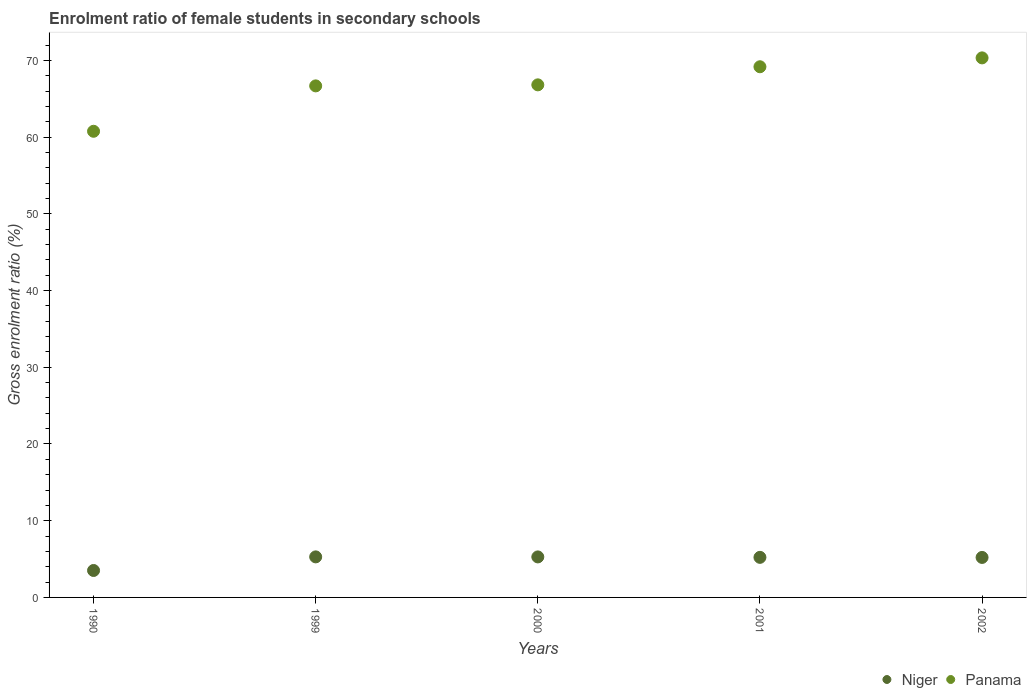How many different coloured dotlines are there?
Ensure brevity in your answer.  2. Is the number of dotlines equal to the number of legend labels?
Provide a succinct answer. Yes. What is the enrolment ratio of female students in secondary schools in Niger in 1999?
Keep it short and to the point. 5.28. Across all years, what is the maximum enrolment ratio of female students in secondary schools in Niger?
Offer a terse response. 5.28. Across all years, what is the minimum enrolment ratio of female students in secondary schools in Niger?
Your response must be concise. 3.51. In which year was the enrolment ratio of female students in secondary schools in Niger maximum?
Keep it short and to the point. 1999. In which year was the enrolment ratio of female students in secondary schools in Niger minimum?
Make the answer very short. 1990. What is the total enrolment ratio of female students in secondary schools in Panama in the graph?
Ensure brevity in your answer.  333.75. What is the difference between the enrolment ratio of female students in secondary schools in Niger in 1999 and that in 2002?
Your answer should be compact. 0.07. What is the difference between the enrolment ratio of female students in secondary schools in Niger in 2002 and the enrolment ratio of female students in secondary schools in Panama in 2000?
Provide a succinct answer. -61.6. What is the average enrolment ratio of female students in secondary schools in Niger per year?
Your answer should be compact. 4.9. In the year 2002, what is the difference between the enrolment ratio of female students in secondary schools in Panama and enrolment ratio of female students in secondary schools in Niger?
Give a very brief answer. 65.11. What is the ratio of the enrolment ratio of female students in secondary schools in Niger in 1990 to that in 1999?
Offer a terse response. 0.66. Is the difference between the enrolment ratio of female students in secondary schools in Panama in 1990 and 2000 greater than the difference between the enrolment ratio of female students in secondary schools in Niger in 1990 and 2000?
Offer a terse response. No. What is the difference between the highest and the second highest enrolment ratio of female students in secondary schools in Panama?
Keep it short and to the point. 1.16. What is the difference between the highest and the lowest enrolment ratio of female students in secondary schools in Niger?
Provide a succinct answer. 1.77. Is the enrolment ratio of female students in secondary schools in Niger strictly less than the enrolment ratio of female students in secondary schools in Panama over the years?
Offer a terse response. Yes. How many dotlines are there?
Provide a succinct answer. 2. What is the difference between two consecutive major ticks on the Y-axis?
Your response must be concise. 10. Does the graph contain grids?
Your answer should be very brief. No. What is the title of the graph?
Offer a terse response. Enrolment ratio of female students in secondary schools. What is the label or title of the Y-axis?
Provide a short and direct response. Gross enrolment ratio (%). What is the Gross enrolment ratio (%) of Niger in 1990?
Your answer should be very brief. 3.51. What is the Gross enrolment ratio (%) of Panama in 1990?
Make the answer very short. 60.76. What is the Gross enrolment ratio (%) of Niger in 1999?
Offer a terse response. 5.28. What is the Gross enrolment ratio (%) in Panama in 1999?
Your answer should be compact. 66.68. What is the Gross enrolment ratio (%) of Niger in 2000?
Your answer should be very brief. 5.28. What is the Gross enrolment ratio (%) of Panama in 2000?
Your answer should be very brief. 66.81. What is the Gross enrolment ratio (%) in Niger in 2001?
Provide a succinct answer. 5.22. What is the Gross enrolment ratio (%) in Panama in 2001?
Offer a terse response. 69.17. What is the Gross enrolment ratio (%) in Niger in 2002?
Make the answer very short. 5.21. What is the Gross enrolment ratio (%) in Panama in 2002?
Your answer should be compact. 70.33. Across all years, what is the maximum Gross enrolment ratio (%) in Niger?
Offer a terse response. 5.28. Across all years, what is the maximum Gross enrolment ratio (%) of Panama?
Make the answer very short. 70.33. Across all years, what is the minimum Gross enrolment ratio (%) of Niger?
Your answer should be very brief. 3.51. Across all years, what is the minimum Gross enrolment ratio (%) of Panama?
Give a very brief answer. 60.76. What is the total Gross enrolment ratio (%) of Niger in the graph?
Your answer should be compact. 24.51. What is the total Gross enrolment ratio (%) in Panama in the graph?
Provide a short and direct response. 333.75. What is the difference between the Gross enrolment ratio (%) in Niger in 1990 and that in 1999?
Keep it short and to the point. -1.77. What is the difference between the Gross enrolment ratio (%) in Panama in 1990 and that in 1999?
Provide a succinct answer. -5.92. What is the difference between the Gross enrolment ratio (%) in Niger in 1990 and that in 2000?
Your response must be concise. -1.77. What is the difference between the Gross enrolment ratio (%) in Panama in 1990 and that in 2000?
Your response must be concise. -6.05. What is the difference between the Gross enrolment ratio (%) of Niger in 1990 and that in 2001?
Provide a succinct answer. -1.71. What is the difference between the Gross enrolment ratio (%) of Panama in 1990 and that in 2001?
Offer a very short reply. -8.41. What is the difference between the Gross enrolment ratio (%) of Niger in 1990 and that in 2002?
Offer a terse response. -1.7. What is the difference between the Gross enrolment ratio (%) of Panama in 1990 and that in 2002?
Your response must be concise. -9.57. What is the difference between the Gross enrolment ratio (%) of Niger in 1999 and that in 2000?
Offer a very short reply. 0. What is the difference between the Gross enrolment ratio (%) in Panama in 1999 and that in 2000?
Your answer should be very brief. -0.13. What is the difference between the Gross enrolment ratio (%) in Niger in 1999 and that in 2001?
Make the answer very short. 0.06. What is the difference between the Gross enrolment ratio (%) of Panama in 1999 and that in 2001?
Provide a short and direct response. -2.49. What is the difference between the Gross enrolment ratio (%) of Niger in 1999 and that in 2002?
Keep it short and to the point. 0.07. What is the difference between the Gross enrolment ratio (%) of Panama in 1999 and that in 2002?
Your response must be concise. -3.65. What is the difference between the Gross enrolment ratio (%) of Niger in 2000 and that in 2001?
Offer a very short reply. 0.06. What is the difference between the Gross enrolment ratio (%) in Panama in 2000 and that in 2001?
Your answer should be compact. -2.36. What is the difference between the Gross enrolment ratio (%) of Niger in 2000 and that in 2002?
Give a very brief answer. 0.07. What is the difference between the Gross enrolment ratio (%) in Panama in 2000 and that in 2002?
Your response must be concise. -3.52. What is the difference between the Gross enrolment ratio (%) in Niger in 2001 and that in 2002?
Your answer should be very brief. 0.01. What is the difference between the Gross enrolment ratio (%) in Panama in 2001 and that in 2002?
Keep it short and to the point. -1.16. What is the difference between the Gross enrolment ratio (%) of Niger in 1990 and the Gross enrolment ratio (%) of Panama in 1999?
Offer a terse response. -63.17. What is the difference between the Gross enrolment ratio (%) of Niger in 1990 and the Gross enrolment ratio (%) of Panama in 2000?
Offer a very short reply. -63.3. What is the difference between the Gross enrolment ratio (%) of Niger in 1990 and the Gross enrolment ratio (%) of Panama in 2001?
Your response must be concise. -65.66. What is the difference between the Gross enrolment ratio (%) of Niger in 1990 and the Gross enrolment ratio (%) of Panama in 2002?
Provide a short and direct response. -66.82. What is the difference between the Gross enrolment ratio (%) of Niger in 1999 and the Gross enrolment ratio (%) of Panama in 2000?
Ensure brevity in your answer.  -61.53. What is the difference between the Gross enrolment ratio (%) of Niger in 1999 and the Gross enrolment ratio (%) of Panama in 2001?
Keep it short and to the point. -63.89. What is the difference between the Gross enrolment ratio (%) of Niger in 1999 and the Gross enrolment ratio (%) of Panama in 2002?
Your answer should be very brief. -65.04. What is the difference between the Gross enrolment ratio (%) of Niger in 2000 and the Gross enrolment ratio (%) of Panama in 2001?
Keep it short and to the point. -63.89. What is the difference between the Gross enrolment ratio (%) in Niger in 2000 and the Gross enrolment ratio (%) in Panama in 2002?
Make the answer very short. -65.05. What is the difference between the Gross enrolment ratio (%) of Niger in 2001 and the Gross enrolment ratio (%) of Panama in 2002?
Provide a short and direct response. -65.1. What is the average Gross enrolment ratio (%) in Niger per year?
Your response must be concise. 4.9. What is the average Gross enrolment ratio (%) of Panama per year?
Ensure brevity in your answer.  66.75. In the year 1990, what is the difference between the Gross enrolment ratio (%) in Niger and Gross enrolment ratio (%) in Panama?
Provide a succinct answer. -57.25. In the year 1999, what is the difference between the Gross enrolment ratio (%) in Niger and Gross enrolment ratio (%) in Panama?
Make the answer very short. -61.39. In the year 2000, what is the difference between the Gross enrolment ratio (%) of Niger and Gross enrolment ratio (%) of Panama?
Your answer should be very brief. -61.53. In the year 2001, what is the difference between the Gross enrolment ratio (%) of Niger and Gross enrolment ratio (%) of Panama?
Your response must be concise. -63.95. In the year 2002, what is the difference between the Gross enrolment ratio (%) in Niger and Gross enrolment ratio (%) in Panama?
Provide a short and direct response. -65.11. What is the ratio of the Gross enrolment ratio (%) in Niger in 1990 to that in 1999?
Provide a succinct answer. 0.66. What is the ratio of the Gross enrolment ratio (%) of Panama in 1990 to that in 1999?
Make the answer very short. 0.91. What is the ratio of the Gross enrolment ratio (%) in Niger in 1990 to that in 2000?
Keep it short and to the point. 0.67. What is the ratio of the Gross enrolment ratio (%) of Panama in 1990 to that in 2000?
Your response must be concise. 0.91. What is the ratio of the Gross enrolment ratio (%) of Niger in 1990 to that in 2001?
Your answer should be compact. 0.67. What is the ratio of the Gross enrolment ratio (%) of Panama in 1990 to that in 2001?
Make the answer very short. 0.88. What is the ratio of the Gross enrolment ratio (%) in Niger in 1990 to that in 2002?
Keep it short and to the point. 0.67. What is the ratio of the Gross enrolment ratio (%) of Panama in 1990 to that in 2002?
Make the answer very short. 0.86. What is the ratio of the Gross enrolment ratio (%) in Niger in 1999 to that in 2001?
Your response must be concise. 1.01. What is the ratio of the Gross enrolment ratio (%) in Niger in 1999 to that in 2002?
Your answer should be compact. 1.01. What is the ratio of the Gross enrolment ratio (%) in Panama in 1999 to that in 2002?
Provide a succinct answer. 0.95. What is the ratio of the Gross enrolment ratio (%) in Niger in 2000 to that in 2001?
Keep it short and to the point. 1.01. What is the ratio of the Gross enrolment ratio (%) of Panama in 2000 to that in 2001?
Give a very brief answer. 0.97. What is the ratio of the Gross enrolment ratio (%) of Niger in 2000 to that in 2002?
Keep it short and to the point. 1.01. What is the ratio of the Gross enrolment ratio (%) of Panama in 2001 to that in 2002?
Your answer should be compact. 0.98. What is the difference between the highest and the second highest Gross enrolment ratio (%) in Niger?
Your response must be concise. 0. What is the difference between the highest and the second highest Gross enrolment ratio (%) in Panama?
Give a very brief answer. 1.16. What is the difference between the highest and the lowest Gross enrolment ratio (%) in Niger?
Provide a short and direct response. 1.77. What is the difference between the highest and the lowest Gross enrolment ratio (%) in Panama?
Make the answer very short. 9.57. 